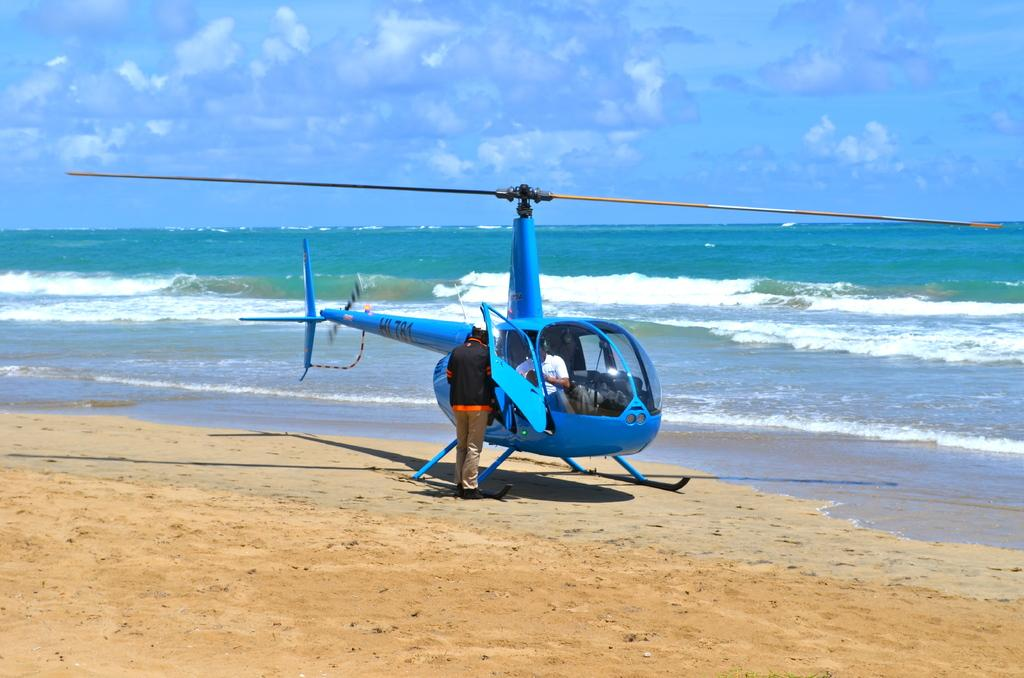What is the main subject of the image? The main subject of the image is a helicopter. Can you describe the helicopter's occupants? There is a person inside the helicopter. What is the person standing in front of the helicopter doing? The person is standing in front of the helicopter, but their actions are not specified. What can be seen in the background of the image? There is a river and the sky visible in the background of the image. How many goldfish are swimming in the river in the image? There are no goldfish visible in the image; it only shows a helicopter, a person inside it, a person standing in front of it, and the river and sky in the background. 